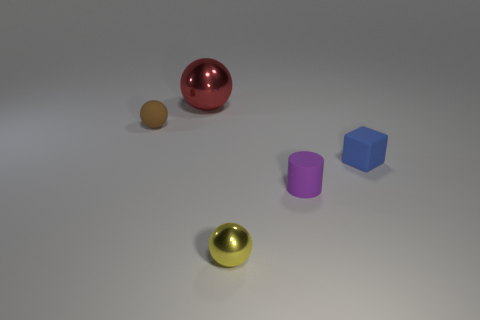Add 1 tiny brown matte cubes. How many objects exist? 6 Subtract all balls. How many objects are left? 2 Subtract all green things. Subtract all small yellow objects. How many objects are left? 4 Add 4 tiny blue objects. How many tiny blue objects are left? 5 Add 5 big red objects. How many big red objects exist? 6 Subtract 1 blue cubes. How many objects are left? 4 